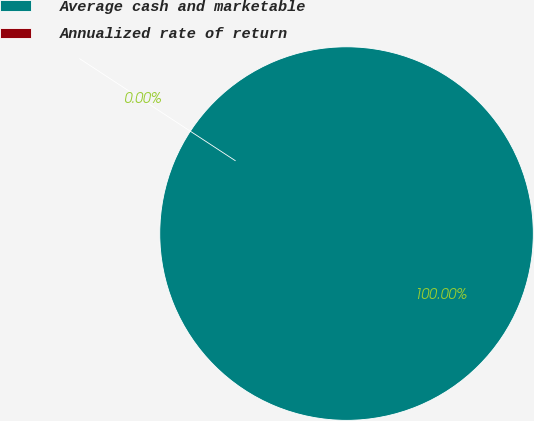Convert chart. <chart><loc_0><loc_0><loc_500><loc_500><pie_chart><fcel>Average cash and marketable<fcel>Annualized rate of return<nl><fcel>100.0%<fcel>0.0%<nl></chart> 